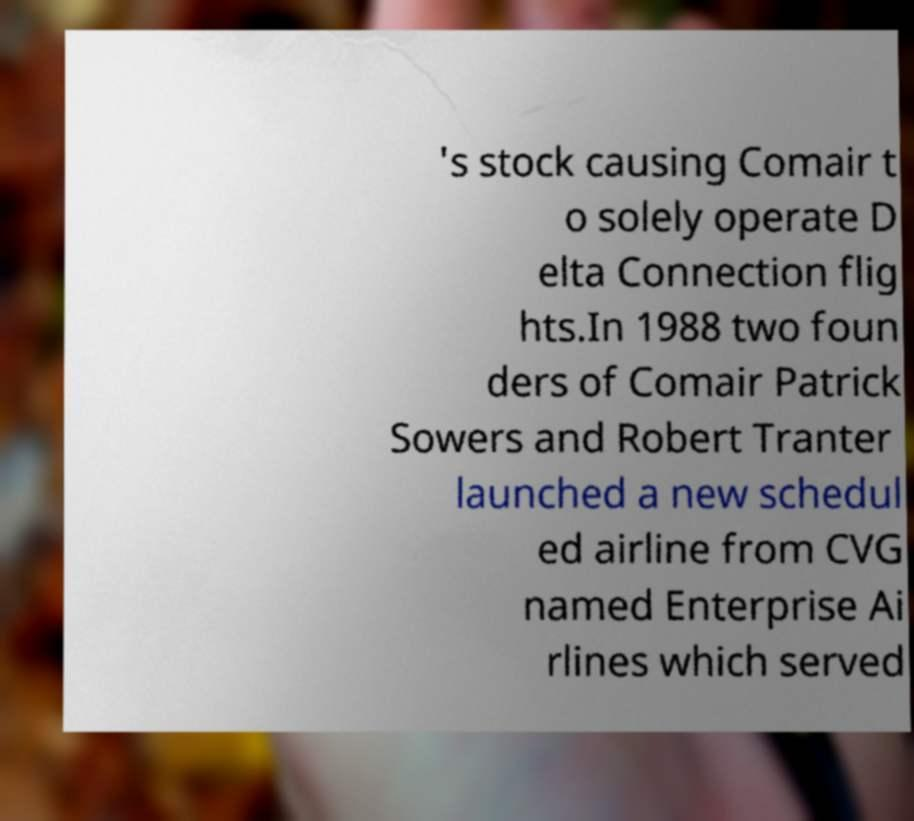I need the written content from this picture converted into text. Can you do that? 's stock causing Comair t o solely operate D elta Connection flig hts.In 1988 two foun ders of Comair Patrick Sowers and Robert Tranter launched a new schedul ed airline from CVG named Enterprise Ai rlines which served 